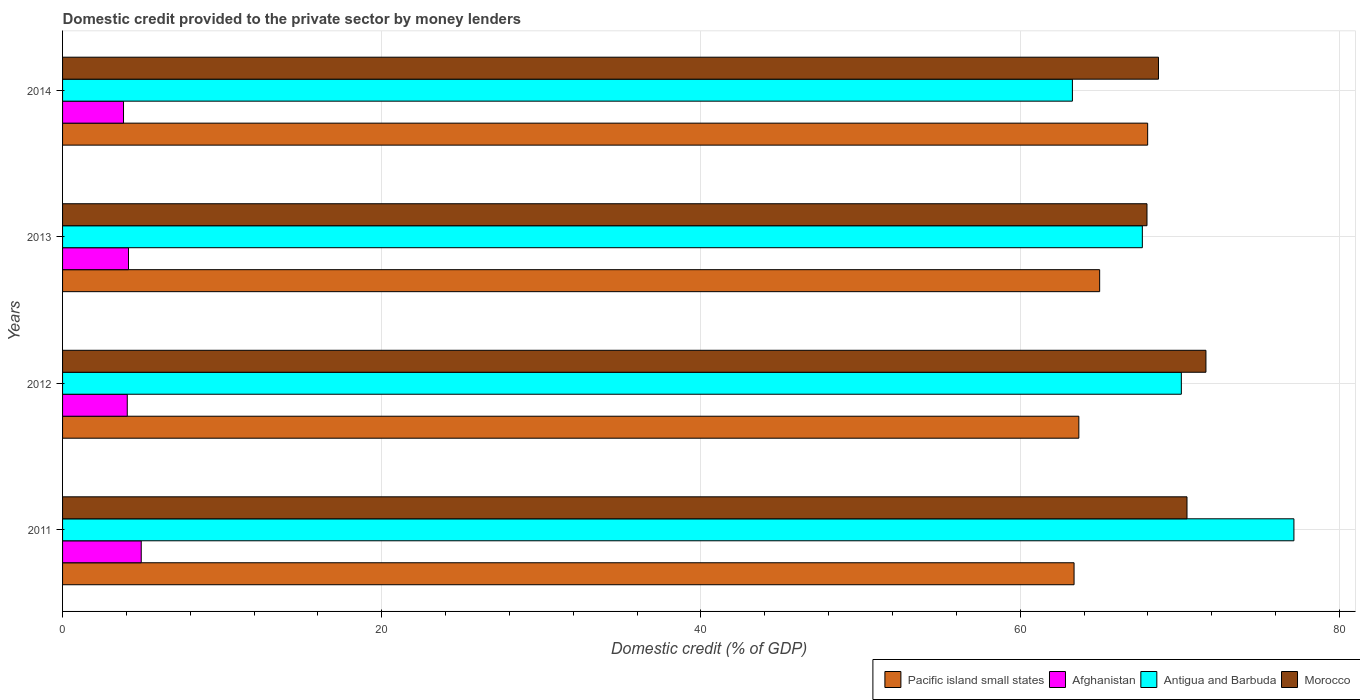How many different coloured bars are there?
Ensure brevity in your answer.  4. How many groups of bars are there?
Keep it short and to the point. 4. What is the domestic credit provided to the private sector by money lenders in Afghanistan in 2011?
Give a very brief answer. 4.93. Across all years, what is the maximum domestic credit provided to the private sector by money lenders in Afghanistan?
Keep it short and to the point. 4.93. Across all years, what is the minimum domestic credit provided to the private sector by money lenders in Antigua and Barbuda?
Keep it short and to the point. 63.27. What is the total domestic credit provided to the private sector by money lenders in Afghanistan in the graph?
Keep it short and to the point. 16.93. What is the difference between the domestic credit provided to the private sector by money lenders in Afghanistan in 2013 and that in 2014?
Offer a very short reply. 0.31. What is the difference between the domestic credit provided to the private sector by money lenders in Antigua and Barbuda in 2014 and the domestic credit provided to the private sector by money lenders in Pacific island small states in 2012?
Offer a terse response. -0.4. What is the average domestic credit provided to the private sector by money lenders in Pacific island small states per year?
Offer a very short reply. 65. In the year 2011, what is the difference between the domestic credit provided to the private sector by money lenders in Morocco and domestic credit provided to the private sector by money lenders in Pacific island small states?
Your answer should be very brief. 7.08. In how many years, is the domestic credit provided to the private sector by money lenders in Morocco greater than 68 %?
Offer a terse response. 3. What is the ratio of the domestic credit provided to the private sector by money lenders in Pacific island small states in 2012 to that in 2014?
Keep it short and to the point. 0.94. What is the difference between the highest and the second highest domestic credit provided to the private sector by money lenders in Morocco?
Make the answer very short. 1.19. What is the difference between the highest and the lowest domestic credit provided to the private sector by money lenders in Pacific island small states?
Your response must be concise. 4.61. What does the 1st bar from the top in 2014 represents?
Your answer should be very brief. Morocco. What does the 3rd bar from the bottom in 2013 represents?
Your answer should be very brief. Antigua and Barbuda. How many bars are there?
Your response must be concise. 16. Are the values on the major ticks of X-axis written in scientific E-notation?
Your response must be concise. No. Does the graph contain any zero values?
Give a very brief answer. No. Does the graph contain grids?
Give a very brief answer. Yes. How many legend labels are there?
Your answer should be very brief. 4. How are the legend labels stacked?
Your answer should be very brief. Horizontal. What is the title of the graph?
Offer a terse response. Domestic credit provided to the private sector by money lenders. Does "Peru" appear as one of the legend labels in the graph?
Your response must be concise. No. What is the label or title of the X-axis?
Make the answer very short. Domestic credit (% of GDP). What is the Domestic credit (% of GDP) in Pacific island small states in 2011?
Offer a terse response. 63.38. What is the Domestic credit (% of GDP) of Afghanistan in 2011?
Your answer should be compact. 4.93. What is the Domestic credit (% of GDP) of Antigua and Barbuda in 2011?
Ensure brevity in your answer.  77.15. What is the Domestic credit (% of GDP) of Morocco in 2011?
Offer a terse response. 70.45. What is the Domestic credit (% of GDP) in Pacific island small states in 2012?
Offer a very short reply. 63.67. What is the Domestic credit (% of GDP) in Afghanistan in 2012?
Give a very brief answer. 4.05. What is the Domestic credit (% of GDP) of Antigua and Barbuda in 2012?
Provide a succinct answer. 70.1. What is the Domestic credit (% of GDP) in Morocco in 2012?
Ensure brevity in your answer.  71.64. What is the Domestic credit (% of GDP) in Pacific island small states in 2013?
Offer a terse response. 64.98. What is the Domestic credit (% of GDP) of Afghanistan in 2013?
Your answer should be compact. 4.13. What is the Domestic credit (% of GDP) in Antigua and Barbuda in 2013?
Your answer should be very brief. 67.65. What is the Domestic credit (% of GDP) of Morocco in 2013?
Provide a short and direct response. 67.94. What is the Domestic credit (% of GDP) in Pacific island small states in 2014?
Offer a terse response. 67.99. What is the Domestic credit (% of GDP) in Afghanistan in 2014?
Your response must be concise. 3.82. What is the Domestic credit (% of GDP) of Antigua and Barbuda in 2014?
Your answer should be compact. 63.27. What is the Domestic credit (% of GDP) in Morocco in 2014?
Ensure brevity in your answer.  68.66. Across all years, what is the maximum Domestic credit (% of GDP) in Pacific island small states?
Provide a succinct answer. 67.99. Across all years, what is the maximum Domestic credit (% of GDP) in Afghanistan?
Your response must be concise. 4.93. Across all years, what is the maximum Domestic credit (% of GDP) in Antigua and Barbuda?
Your answer should be very brief. 77.15. Across all years, what is the maximum Domestic credit (% of GDP) of Morocco?
Ensure brevity in your answer.  71.64. Across all years, what is the minimum Domestic credit (% of GDP) in Pacific island small states?
Ensure brevity in your answer.  63.38. Across all years, what is the minimum Domestic credit (% of GDP) of Afghanistan?
Your answer should be compact. 3.82. Across all years, what is the minimum Domestic credit (% of GDP) of Antigua and Barbuda?
Provide a short and direct response. 63.27. Across all years, what is the minimum Domestic credit (% of GDP) in Morocco?
Your answer should be compact. 67.94. What is the total Domestic credit (% of GDP) of Pacific island small states in the graph?
Offer a very short reply. 260.02. What is the total Domestic credit (% of GDP) of Afghanistan in the graph?
Provide a short and direct response. 16.93. What is the total Domestic credit (% of GDP) of Antigua and Barbuda in the graph?
Provide a succinct answer. 278.17. What is the total Domestic credit (% of GDP) of Morocco in the graph?
Give a very brief answer. 278.7. What is the difference between the Domestic credit (% of GDP) in Pacific island small states in 2011 and that in 2012?
Your answer should be very brief. -0.3. What is the difference between the Domestic credit (% of GDP) in Antigua and Barbuda in 2011 and that in 2012?
Provide a short and direct response. 7.05. What is the difference between the Domestic credit (% of GDP) of Morocco in 2011 and that in 2012?
Offer a very short reply. -1.19. What is the difference between the Domestic credit (% of GDP) of Pacific island small states in 2011 and that in 2013?
Keep it short and to the point. -1.6. What is the difference between the Domestic credit (% of GDP) of Afghanistan in 2011 and that in 2013?
Your answer should be compact. 0.8. What is the difference between the Domestic credit (% of GDP) in Antigua and Barbuda in 2011 and that in 2013?
Your response must be concise. 9.5. What is the difference between the Domestic credit (% of GDP) of Morocco in 2011 and that in 2013?
Provide a short and direct response. 2.51. What is the difference between the Domestic credit (% of GDP) in Pacific island small states in 2011 and that in 2014?
Give a very brief answer. -4.61. What is the difference between the Domestic credit (% of GDP) in Afghanistan in 2011 and that in 2014?
Ensure brevity in your answer.  1.11. What is the difference between the Domestic credit (% of GDP) in Antigua and Barbuda in 2011 and that in 2014?
Offer a very short reply. 13.88. What is the difference between the Domestic credit (% of GDP) in Morocco in 2011 and that in 2014?
Keep it short and to the point. 1.79. What is the difference between the Domestic credit (% of GDP) of Pacific island small states in 2012 and that in 2013?
Give a very brief answer. -1.3. What is the difference between the Domestic credit (% of GDP) in Afghanistan in 2012 and that in 2013?
Keep it short and to the point. -0.08. What is the difference between the Domestic credit (% of GDP) in Antigua and Barbuda in 2012 and that in 2013?
Provide a short and direct response. 2.44. What is the difference between the Domestic credit (% of GDP) of Morocco in 2012 and that in 2013?
Ensure brevity in your answer.  3.69. What is the difference between the Domestic credit (% of GDP) in Pacific island small states in 2012 and that in 2014?
Offer a very short reply. -4.31. What is the difference between the Domestic credit (% of GDP) of Afghanistan in 2012 and that in 2014?
Your response must be concise. 0.24. What is the difference between the Domestic credit (% of GDP) in Antigua and Barbuda in 2012 and that in 2014?
Your response must be concise. 6.83. What is the difference between the Domestic credit (% of GDP) in Morocco in 2012 and that in 2014?
Give a very brief answer. 2.97. What is the difference between the Domestic credit (% of GDP) in Pacific island small states in 2013 and that in 2014?
Offer a terse response. -3.01. What is the difference between the Domestic credit (% of GDP) in Afghanistan in 2013 and that in 2014?
Make the answer very short. 0.31. What is the difference between the Domestic credit (% of GDP) in Antigua and Barbuda in 2013 and that in 2014?
Ensure brevity in your answer.  4.38. What is the difference between the Domestic credit (% of GDP) of Morocco in 2013 and that in 2014?
Your response must be concise. -0.72. What is the difference between the Domestic credit (% of GDP) in Pacific island small states in 2011 and the Domestic credit (% of GDP) in Afghanistan in 2012?
Make the answer very short. 59.32. What is the difference between the Domestic credit (% of GDP) in Pacific island small states in 2011 and the Domestic credit (% of GDP) in Antigua and Barbuda in 2012?
Make the answer very short. -6.72. What is the difference between the Domestic credit (% of GDP) of Pacific island small states in 2011 and the Domestic credit (% of GDP) of Morocco in 2012?
Offer a very short reply. -8.26. What is the difference between the Domestic credit (% of GDP) of Afghanistan in 2011 and the Domestic credit (% of GDP) of Antigua and Barbuda in 2012?
Your response must be concise. -65.17. What is the difference between the Domestic credit (% of GDP) in Afghanistan in 2011 and the Domestic credit (% of GDP) in Morocco in 2012?
Keep it short and to the point. -66.71. What is the difference between the Domestic credit (% of GDP) of Antigua and Barbuda in 2011 and the Domestic credit (% of GDP) of Morocco in 2012?
Your answer should be compact. 5.51. What is the difference between the Domestic credit (% of GDP) of Pacific island small states in 2011 and the Domestic credit (% of GDP) of Afghanistan in 2013?
Provide a short and direct response. 59.24. What is the difference between the Domestic credit (% of GDP) of Pacific island small states in 2011 and the Domestic credit (% of GDP) of Antigua and Barbuda in 2013?
Give a very brief answer. -4.28. What is the difference between the Domestic credit (% of GDP) of Pacific island small states in 2011 and the Domestic credit (% of GDP) of Morocco in 2013?
Keep it short and to the point. -4.57. What is the difference between the Domestic credit (% of GDP) in Afghanistan in 2011 and the Domestic credit (% of GDP) in Antigua and Barbuda in 2013?
Your answer should be very brief. -62.72. What is the difference between the Domestic credit (% of GDP) of Afghanistan in 2011 and the Domestic credit (% of GDP) of Morocco in 2013?
Provide a succinct answer. -63.02. What is the difference between the Domestic credit (% of GDP) in Antigua and Barbuda in 2011 and the Domestic credit (% of GDP) in Morocco in 2013?
Give a very brief answer. 9.21. What is the difference between the Domestic credit (% of GDP) in Pacific island small states in 2011 and the Domestic credit (% of GDP) in Afghanistan in 2014?
Your answer should be very brief. 59.56. What is the difference between the Domestic credit (% of GDP) in Pacific island small states in 2011 and the Domestic credit (% of GDP) in Antigua and Barbuda in 2014?
Offer a terse response. 0.1. What is the difference between the Domestic credit (% of GDP) in Pacific island small states in 2011 and the Domestic credit (% of GDP) in Morocco in 2014?
Offer a very short reply. -5.29. What is the difference between the Domestic credit (% of GDP) of Afghanistan in 2011 and the Domestic credit (% of GDP) of Antigua and Barbuda in 2014?
Give a very brief answer. -58.34. What is the difference between the Domestic credit (% of GDP) in Afghanistan in 2011 and the Domestic credit (% of GDP) in Morocco in 2014?
Your response must be concise. -63.74. What is the difference between the Domestic credit (% of GDP) of Antigua and Barbuda in 2011 and the Domestic credit (% of GDP) of Morocco in 2014?
Offer a very short reply. 8.49. What is the difference between the Domestic credit (% of GDP) in Pacific island small states in 2012 and the Domestic credit (% of GDP) in Afghanistan in 2013?
Provide a short and direct response. 59.54. What is the difference between the Domestic credit (% of GDP) of Pacific island small states in 2012 and the Domestic credit (% of GDP) of Antigua and Barbuda in 2013?
Offer a terse response. -3.98. What is the difference between the Domestic credit (% of GDP) in Pacific island small states in 2012 and the Domestic credit (% of GDP) in Morocco in 2013?
Offer a terse response. -4.27. What is the difference between the Domestic credit (% of GDP) of Afghanistan in 2012 and the Domestic credit (% of GDP) of Antigua and Barbuda in 2013?
Provide a short and direct response. -63.6. What is the difference between the Domestic credit (% of GDP) in Afghanistan in 2012 and the Domestic credit (% of GDP) in Morocco in 2013?
Ensure brevity in your answer.  -63.89. What is the difference between the Domestic credit (% of GDP) of Antigua and Barbuda in 2012 and the Domestic credit (% of GDP) of Morocco in 2013?
Ensure brevity in your answer.  2.15. What is the difference between the Domestic credit (% of GDP) of Pacific island small states in 2012 and the Domestic credit (% of GDP) of Afghanistan in 2014?
Provide a succinct answer. 59.86. What is the difference between the Domestic credit (% of GDP) in Pacific island small states in 2012 and the Domestic credit (% of GDP) in Antigua and Barbuda in 2014?
Provide a short and direct response. 0.4. What is the difference between the Domestic credit (% of GDP) of Pacific island small states in 2012 and the Domestic credit (% of GDP) of Morocco in 2014?
Make the answer very short. -4.99. What is the difference between the Domestic credit (% of GDP) in Afghanistan in 2012 and the Domestic credit (% of GDP) in Antigua and Barbuda in 2014?
Make the answer very short. -59.22. What is the difference between the Domestic credit (% of GDP) of Afghanistan in 2012 and the Domestic credit (% of GDP) of Morocco in 2014?
Keep it short and to the point. -64.61. What is the difference between the Domestic credit (% of GDP) of Antigua and Barbuda in 2012 and the Domestic credit (% of GDP) of Morocco in 2014?
Keep it short and to the point. 1.43. What is the difference between the Domestic credit (% of GDP) of Pacific island small states in 2013 and the Domestic credit (% of GDP) of Afghanistan in 2014?
Offer a terse response. 61.16. What is the difference between the Domestic credit (% of GDP) in Pacific island small states in 2013 and the Domestic credit (% of GDP) in Antigua and Barbuda in 2014?
Your answer should be very brief. 1.71. What is the difference between the Domestic credit (% of GDP) of Pacific island small states in 2013 and the Domestic credit (% of GDP) of Morocco in 2014?
Keep it short and to the point. -3.69. What is the difference between the Domestic credit (% of GDP) of Afghanistan in 2013 and the Domestic credit (% of GDP) of Antigua and Barbuda in 2014?
Give a very brief answer. -59.14. What is the difference between the Domestic credit (% of GDP) in Afghanistan in 2013 and the Domestic credit (% of GDP) in Morocco in 2014?
Keep it short and to the point. -64.53. What is the difference between the Domestic credit (% of GDP) of Antigua and Barbuda in 2013 and the Domestic credit (% of GDP) of Morocco in 2014?
Offer a very short reply. -1.01. What is the average Domestic credit (% of GDP) in Pacific island small states per year?
Provide a succinct answer. 65. What is the average Domestic credit (% of GDP) in Afghanistan per year?
Your response must be concise. 4.23. What is the average Domestic credit (% of GDP) of Antigua and Barbuda per year?
Ensure brevity in your answer.  69.54. What is the average Domestic credit (% of GDP) in Morocco per year?
Your answer should be compact. 69.67. In the year 2011, what is the difference between the Domestic credit (% of GDP) of Pacific island small states and Domestic credit (% of GDP) of Afghanistan?
Provide a short and direct response. 58.45. In the year 2011, what is the difference between the Domestic credit (% of GDP) of Pacific island small states and Domestic credit (% of GDP) of Antigua and Barbuda?
Your response must be concise. -13.78. In the year 2011, what is the difference between the Domestic credit (% of GDP) in Pacific island small states and Domestic credit (% of GDP) in Morocco?
Provide a short and direct response. -7.08. In the year 2011, what is the difference between the Domestic credit (% of GDP) of Afghanistan and Domestic credit (% of GDP) of Antigua and Barbuda?
Provide a succinct answer. -72.22. In the year 2011, what is the difference between the Domestic credit (% of GDP) of Afghanistan and Domestic credit (% of GDP) of Morocco?
Give a very brief answer. -65.52. In the year 2011, what is the difference between the Domestic credit (% of GDP) in Antigua and Barbuda and Domestic credit (% of GDP) in Morocco?
Keep it short and to the point. 6.7. In the year 2012, what is the difference between the Domestic credit (% of GDP) in Pacific island small states and Domestic credit (% of GDP) in Afghanistan?
Your answer should be very brief. 59.62. In the year 2012, what is the difference between the Domestic credit (% of GDP) of Pacific island small states and Domestic credit (% of GDP) of Antigua and Barbuda?
Provide a succinct answer. -6.42. In the year 2012, what is the difference between the Domestic credit (% of GDP) in Pacific island small states and Domestic credit (% of GDP) in Morocco?
Offer a terse response. -7.96. In the year 2012, what is the difference between the Domestic credit (% of GDP) of Afghanistan and Domestic credit (% of GDP) of Antigua and Barbuda?
Provide a succinct answer. -66.04. In the year 2012, what is the difference between the Domestic credit (% of GDP) of Afghanistan and Domestic credit (% of GDP) of Morocco?
Make the answer very short. -67.58. In the year 2012, what is the difference between the Domestic credit (% of GDP) of Antigua and Barbuda and Domestic credit (% of GDP) of Morocco?
Provide a short and direct response. -1.54. In the year 2013, what is the difference between the Domestic credit (% of GDP) in Pacific island small states and Domestic credit (% of GDP) in Afghanistan?
Offer a terse response. 60.85. In the year 2013, what is the difference between the Domestic credit (% of GDP) in Pacific island small states and Domestic credit (% of GDP) in Antigua and Barbuda?
Ensure brevity in your answer.  -2.67. In the year 2013, what is the difference between the Domestic credit (% of GDP) in Pacific island small states and Domestic credit (% of GDP) in Morocco?
Ensure brevity in your answer.  -2.97. In the year 2013, what is the difference between the Domestic credit (% of GDP) in Afghanistan and Domestic credit (% of GDP) in Antigua and Barbuda?
Provide a succinct answer. -63.52. In the year 2013, what is the difference between the Domestic credit (% of GDP) of Afghanistan and Domestic credit (% of GDP) of Morocco?
Your answer should be compact. -63.81. In the year 2013, what is the difference between the Domestic credit (% of GDP) in Antigua and Barbuda and Domestic credit (% of GDP) in Morocco?
Provide a succinct answer. -0.29. In the year 2014, what is the difference between the Domestic credit (% of GDP) in Pacific island small states and Domestic credit (% of GDP) in Afghanistan?
Give a very brief answer. 64.17. In the year 2014, what is the difference between the Domestic credit (% of GDP) in Pacific island small states and Domestic credit (% of GDP) in Antigua and Barbuda?
Provide a succinct answer. 4.71. In the year 2014, what is the difference between the Domestic credit (% of GDP) of Pacific island small states and Domestic credit (% of GDP) of Morocco?
Your answer should be compact. -0.68. In the year 2014, what is the difference between the Domestic credit (% of GDP) of Afghanistan and Domestic credit (% of GDP) of Antigua and Barbuda?
Give a very brief answer. -59.45. In the year 2014, what is the difference between the Domestic credit (% of GDP) of Afghanistan and Domestic credit (% of GDP) of Morocco?
Offer a terse response. -64.85. In the year 2014, what is the difference between the Domestic credit (% of GDP) in Antigua and Barbuda and Domestic credit (% of GDP) in Morocco?
Your answer should be compact. -5.39. What is the ratio of the Domestic credit (% of GDP) of Pacific island small states in 2011 to that in 2012?
Offer a very short reply. 1. What is the ratio of the Domestic credit (% of GDP) of Afghanistan in 2011 to that in 2012?
Your response must be concise. 1.22. What is the ratio of the Domestic credit (% of GDP) in Antigua and Barbuda in 2011 to that in 2012?
Your answer should be compact. 1.1. What is the ratio of the Domestic credit (% of GDP) in Morocco in 2011 to that in 2012?
Make the answer very short. 0.98. What is the ratio of the Domestic credit (% of GDP) in Pacific island small states in 2011 to that in 2013?
Provide a short and direct response. 0.98. What is the ratio of the Domestic credit (% of GDP) of Afghanistan in 2011 to that in 2013?
Your answer should be compact. 1.19. What is the ratio of the Domestic credit (% of GDP) of Antigua and Barbuda in 2011 to that in 2013?
Provide a short and direct response. 1.14. What is the ratio of the Domestic credit (% of GDP) of Morocco in 2011 to that in 2013?
Your response must be concise. 1.04. What is the ratio of the Domestic credit (% of GDP) in Pacific island small states in 2011 to that in 2014?
Your answer should be compact. 0.93. What is the ratio of the Domestic credit (% of GDP) in Afghanistan in 2011 to that in 2014?
Offer a terse response. 1.29. What is the ratio of the Domestic credit (% of GDP) of Antigua and Barbuda in 2011 to that in 2014?
Keep it short and to the point. 1.22. What is the ratio of the Domestic credit (% of GDP) in Pacific island small states in 2012 to that in 2013?
Offer a very short reply. 0.98. What is the ratio of the Domestic credit (% of GDP) of Afghanistan in 2012 to that in 2013?
Keep it short and to the point. 0.98. What is the ratio of the Domestic credit (% of GDP) in Antigua and Barbuda in 2012 to that in 2013?
Keep it short and to the point. 1.04. What is the ratio of the Domestic credit (% of GDP) of Morocco in 2012 to that in 2013?
Your answer should be very brief. 1.05. What is the ratio of the Domestic credit (% of GDP) in Pacific island small states in 2012 to that in 2014?
Make the answer very short. 0.94. What is the ratio of the Domestic credit (% of GDP) of Afghanistan in 2012 to that in 2014?
Keep it short and to the point. 1.06. What is the ratio of the Domestic credit (% of GDP) of Antigua and Barbuda in 2012 to that in 2014?
Your answer should be very brief. 1.11. What is the ratio of the Domestic credit (% of GDP) in Morocco in 2012 to that in 2014?
Your response must be concise. 1.04. What is the ratio of the Domestic credit (% of GDP) of Pacific island small states in 2013 to that in 2014?
Keep it short and to the point. 0.96. What is the ratio of the Domestic credit (% of GDP) in Afghanistan in 2013 to that in 2014?
Your answer should be compact. 1.08. What is the ratio of the Domestic credit (% of GDP) of Antigua and Barbuda in 2013 to that in 2014?
Ensure brevity in your answer.  1.07. What is the ratio of the Domestic credit (% of GDP) in Morocco in 2013 to that in 2014?
Keep it short and to the point. 0.99. What is the difference between the highest and the second highest Domestic credit (% of GDP) of Pacific island small states?
Provide a succinct answer. 3.01. What is the difference between the highest and the second highest Domestic credit (% of GDP) in Afghanistan?
Ensure brevity in your answer.  0.8. What is the difference between the highest and the second highest Domestic credit (% of GDP) of Antigua and Barbuda?
Keep it short and to the point. 7.05. What is the difference between the highest and the second highest Domestic credit (% of GDP) of Morocco?
Provide a short and direct response. 1.19. What is the difference between the highest and the lowest Domestic credit (% of GDP) in Pacific island small states?
Keep it short and to the point. 4.61. What is the difference between the highest and the lowest Domestic credit (% of GDP) in Afghanistan?
Give a very brief answer. 1.11. What is the difference between the highest and the lowest Domestic credit (% of GDP) in Antigua and Barbuda?
Offer a terse response. 13.88. What is the difference between the highest and the lowest Domestic credit (% of GDP) in Morocco?
Your answer should be compact. 3.69. 